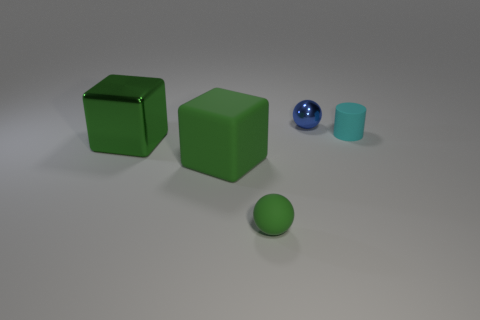Does the tiny rubber sphere have the same color as the big matte object?
Make the answer very short. Yes. How many other objects are there of the same shape as the cyan object?
Ensure brevity in your answer.  0. Are there any spheres?
Your answer should be very brief. Yes. What number of objects are either matte cylinders or balls that are in front of the matte cylinder?
Ensure brevity in your answer.  2. There is a green rubber object behind the green matte sphere; is its size the same as the green metal thing?
Provide a short and direct response. Yes. What number of other objects are there of the same size as the rubber ball?
Ensure brevity in your answer.  2. The cylinder has what color?
Provide a succinct answer. Cyan. What is the material of the small ball that is behind the tiny green object?
Make the answer very short. Metal. Are there an equal number of tiny cyan cylinders that are on the left side of the big green matte object and large purple matte blocks?
Make the answer very short. Yes. Do the small blue metallic thing and the cyan object have the same shape?
Offer a terse response. No. 